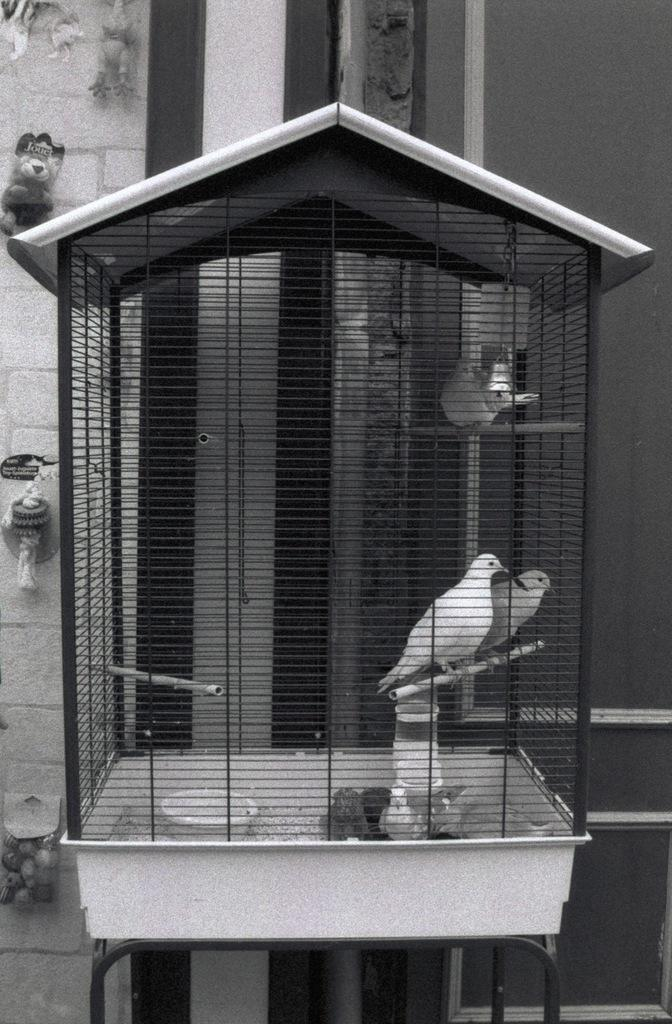What animals can be seen in the image? There are birds in a cage in the image. What type of structure is visible in the image? There is a wall in the image. Where is the teddy bear located in the image? The teddy bear is in the top left of the image. What type of pleasure can be seen being derived from the dirt in the image? There is no dirt present in the image, and therefore no pleasure can be derived from it. 